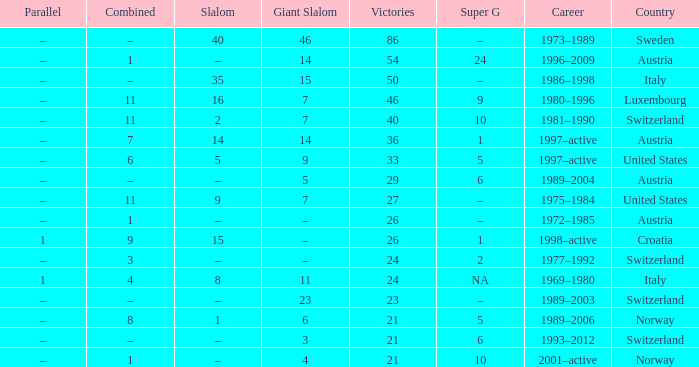What Super G has Victories of 26, and a Country of austria? –. 